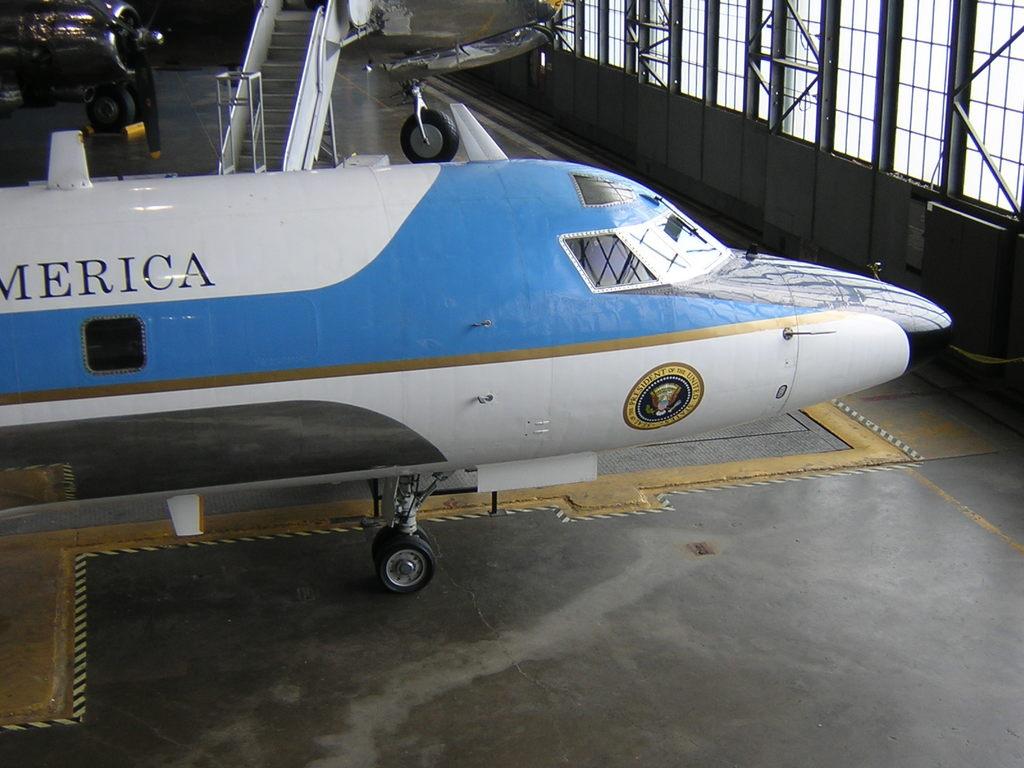What country is written on the side?
Provide a succinct answer. America. 